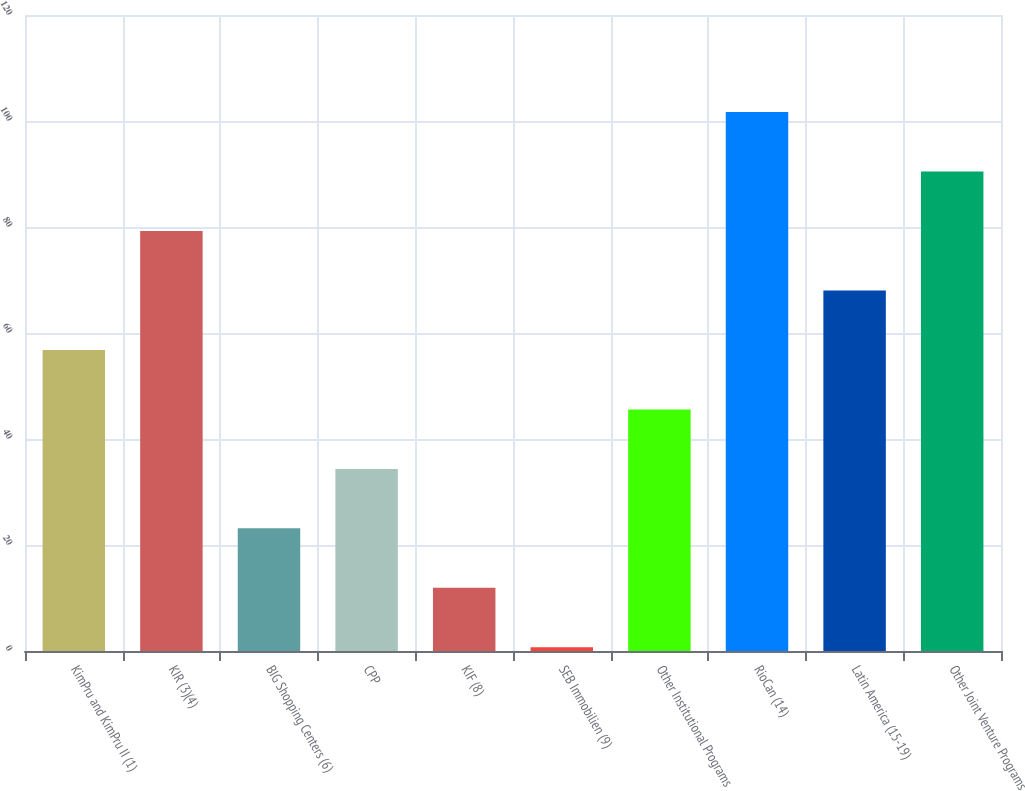<chart> <loc_0><loc_0><loc_500><loc_500><bar_chart><fcel>KimPru and KimPru II (1)<fcel>KIR (3)(4)<fcel>BIG Shopping Centers (6)<fcel>CPP<fcel>KIF (8)<fcel>SEB Immobilien (9)<fcel>Other Institutional Programs<fcel>RioCan (14)<fcel>Latin America (15-19)<fcel>Other Joint Venture Programs<nl><fcel>56.8<fcel>79.24<fcel>23.14<fcel>34.36<fcel>11.92<fcel>0.7<fcel>45.58<fcel>101.68<fcel>68.02<fcel>90.46<nl></chart> 